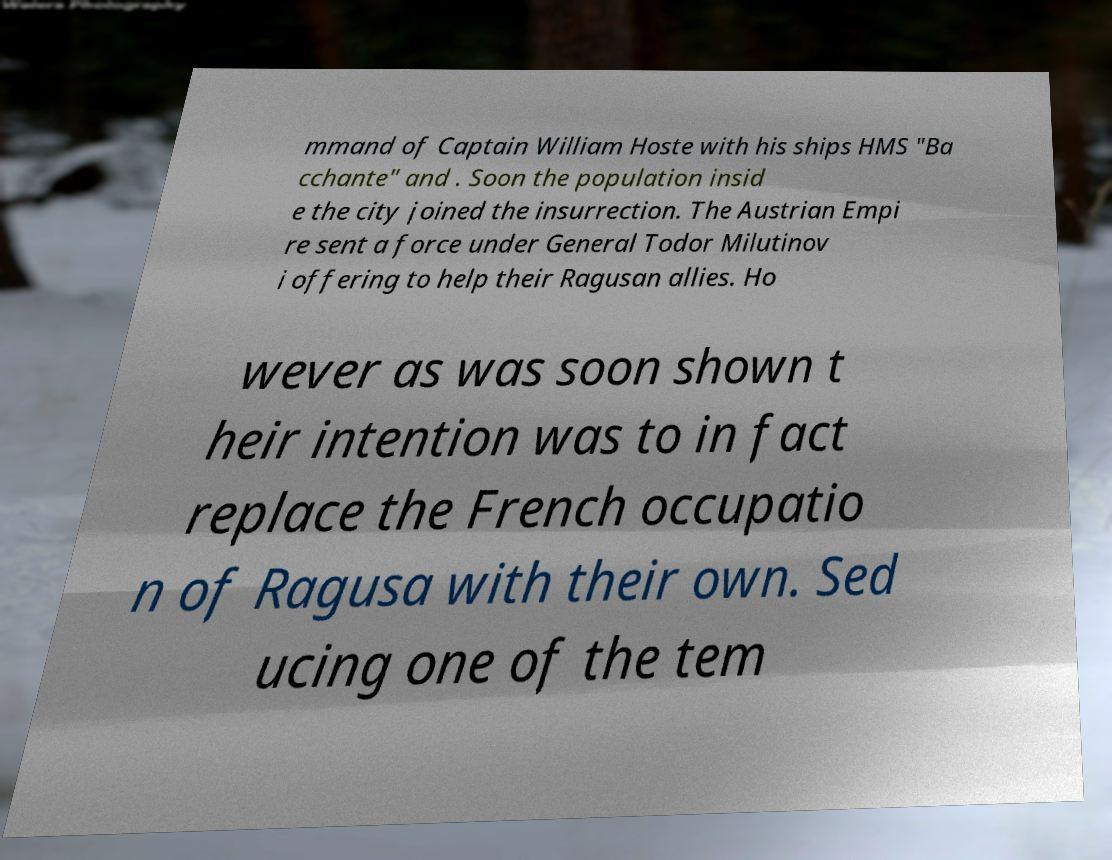Please read and relay the text visible in this image. What does it say? mmand of Captain William Hoste with his ships HMS "Ba cchante" and . Soon the population insid e the city joined the insurrection. The Austrian Empi re sent a force under General Todor Milutinov i offering to help their Ragusan allies. Ho wever as was soon shown t heir intention was to in fact replace the French occupatio n of Ragusa with their own. Sed ucing one of the tem 